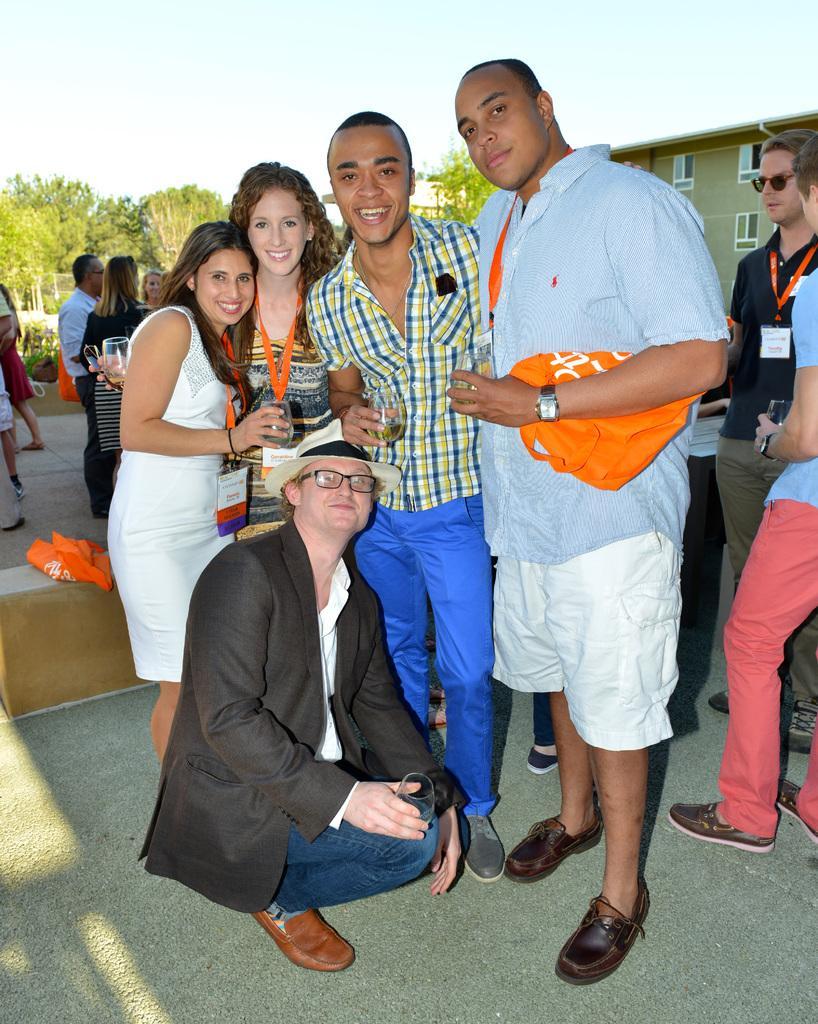Could you give a brief overview of what you see in this image? In the image we can see there are people standing and they are wearing ID cards and holding wine glasses in their hand. There is a person sitting on the ground, behind there is a building and there are trees. There are lot of people standing at the back. 